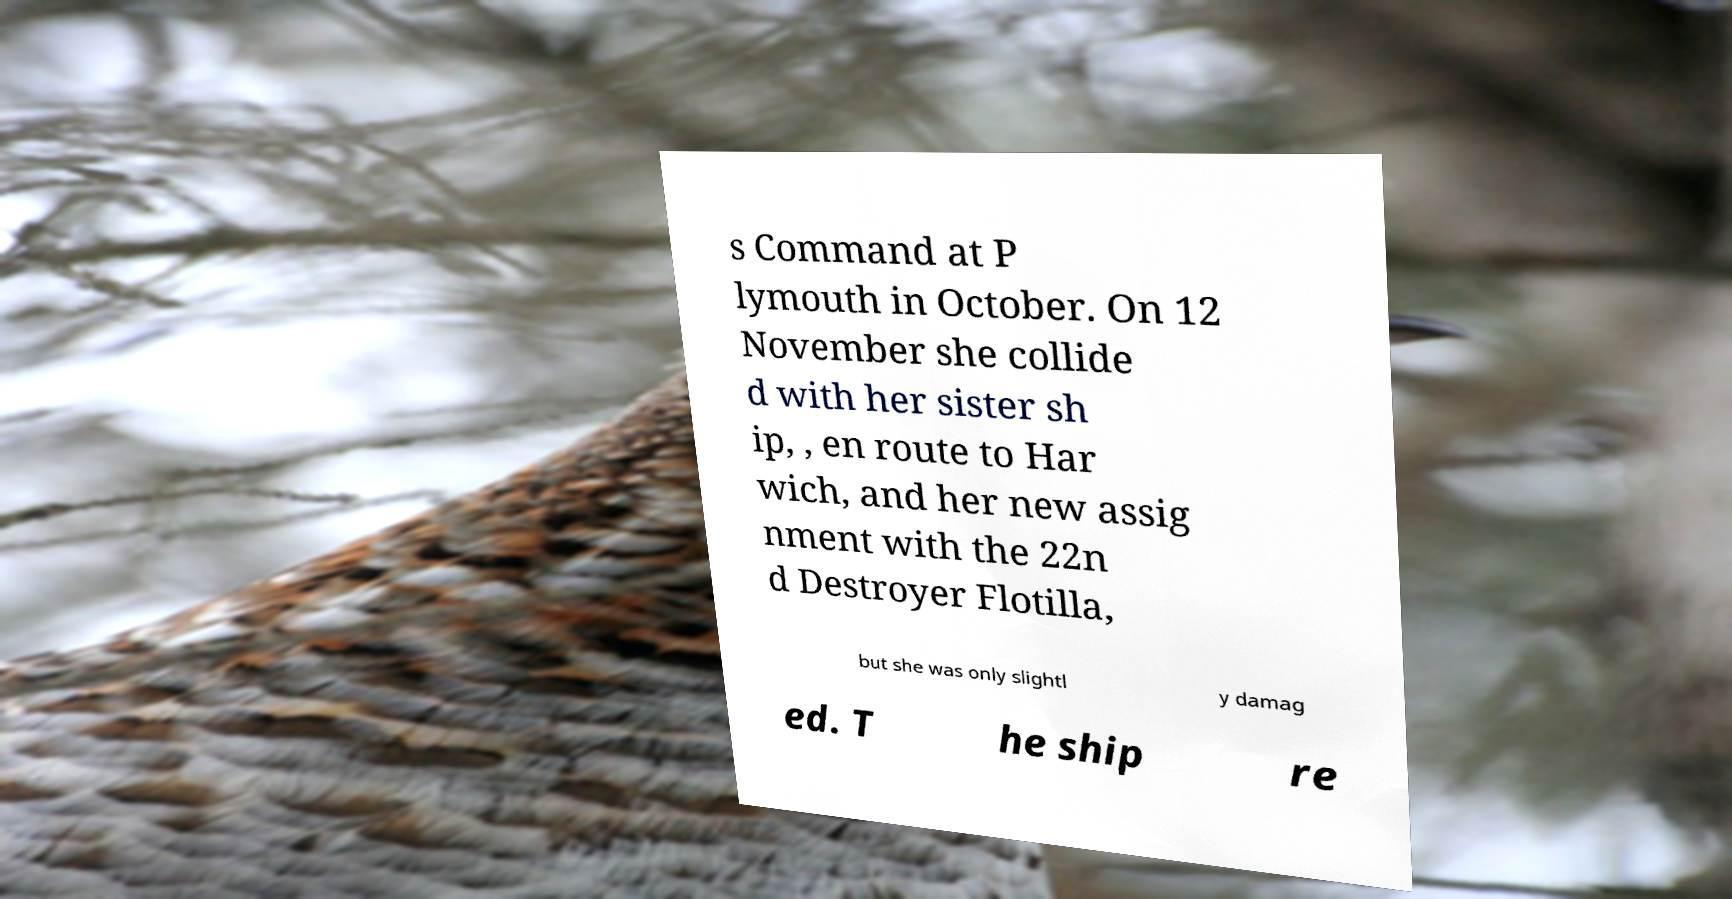For documentation purposes, I need the text within this image transcribed. Could you provide that? s Command at P lymouth in October. On 12 November she collide d with her sister sh ip, , en route to Har wich, and her new assig nment with the 22n d Destroyer Flotilla, but she was only slightl y damag ed. T he ship re 